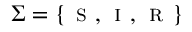Convert formula to latex. <formula><loc_0><loc_0><loc_500><loc_500>\Sigma = \{ s , i , r \}</formula> 